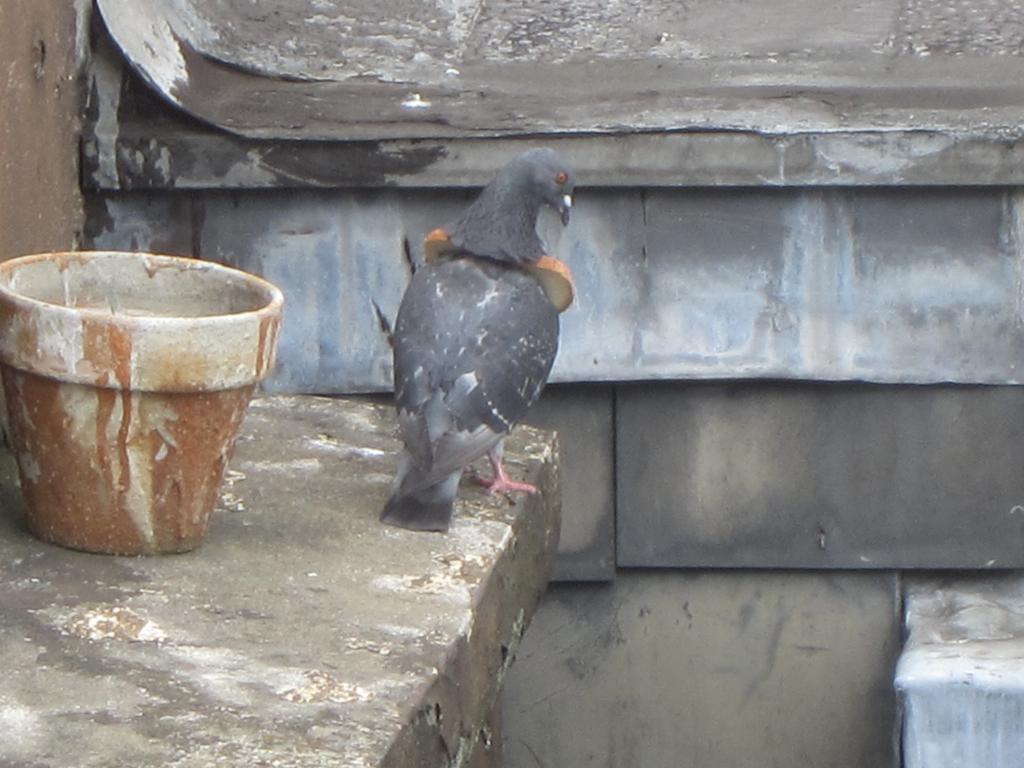Describe this image in one or two sentences. There is a bird standing on the platform and we can see pot and wall. 